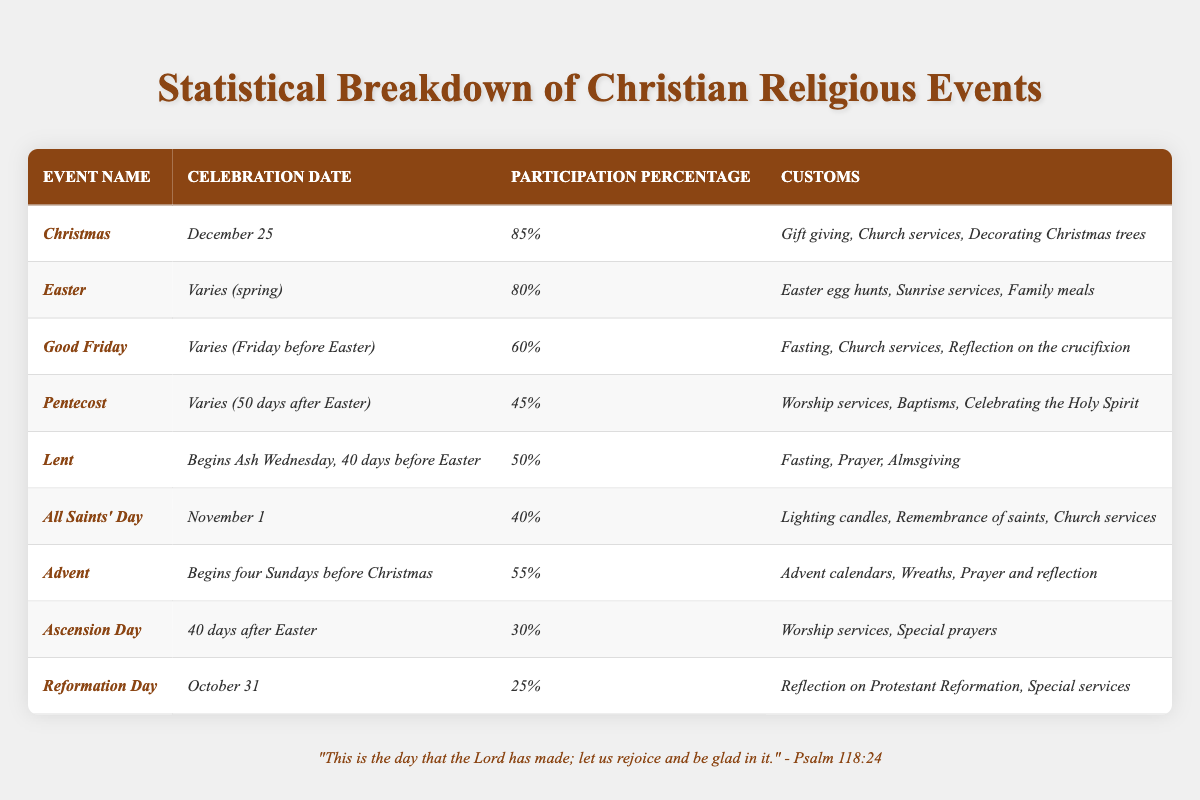What is the celebration date of Christmas? The table shows the celebration date for Christmas clearly listed as December 25.
Answer: December 25 Which religious event has the highest participation percentage? By looking at the participation percentages in the table, Christmas has the highest at 85%.
Answer: Christmas How many events have a participation percentage greater than 50%? Count the events in the table: Christmas (85%), Easter (80%), Good Friday (60%), Lent (50%), and Advent (55%). This gives a total of 4 events with participation greater than 50%.
Answer: 4 Is Good Friday celebrated on a fixed date? Good Friday is listed in the table as occurring on the Friday before Easter, which varies each year, so it does not have a fixed date.
Answer: No What percentage of people participate in Ascension Day? The table specifies that 30% of people participate in Ascension Day.
Answer: 30% Which event has the lowest participation percentage and what is it? By evaluating the participation percentages, Reformation Day has the lowest at 25%.
Answer: Reformation Day, 25% How many events are celebrated in the fall (September to December)? The events occurring in this time frame are Christmas (December 25), Advent (four Sundays before Christmas), and Reformation Day (October 31), totaling 3 events.
Answer: 3 Which event has a custom of "Lighting candles"? All Saints' Day is indicated in the table as having the custom of lighting candles.
Answer: All Saints' Day What is the average participation percentage for Lent, Pentecost, and Ascension Day? First, sum the percentages: Lent (50%) + Pentecost (45%) + Ascension Day (30%) = 125%. Then divide by 3, giving 125% / 3 = 41.67%.
Answer: 41.67% How does the participation in Easter compare to that of Good Friday? Easter has a participation percentage of 80%, while Good Friday has 60%. Easter is more widely participated in than Good Friday.
Answer: Easter is more participated in 